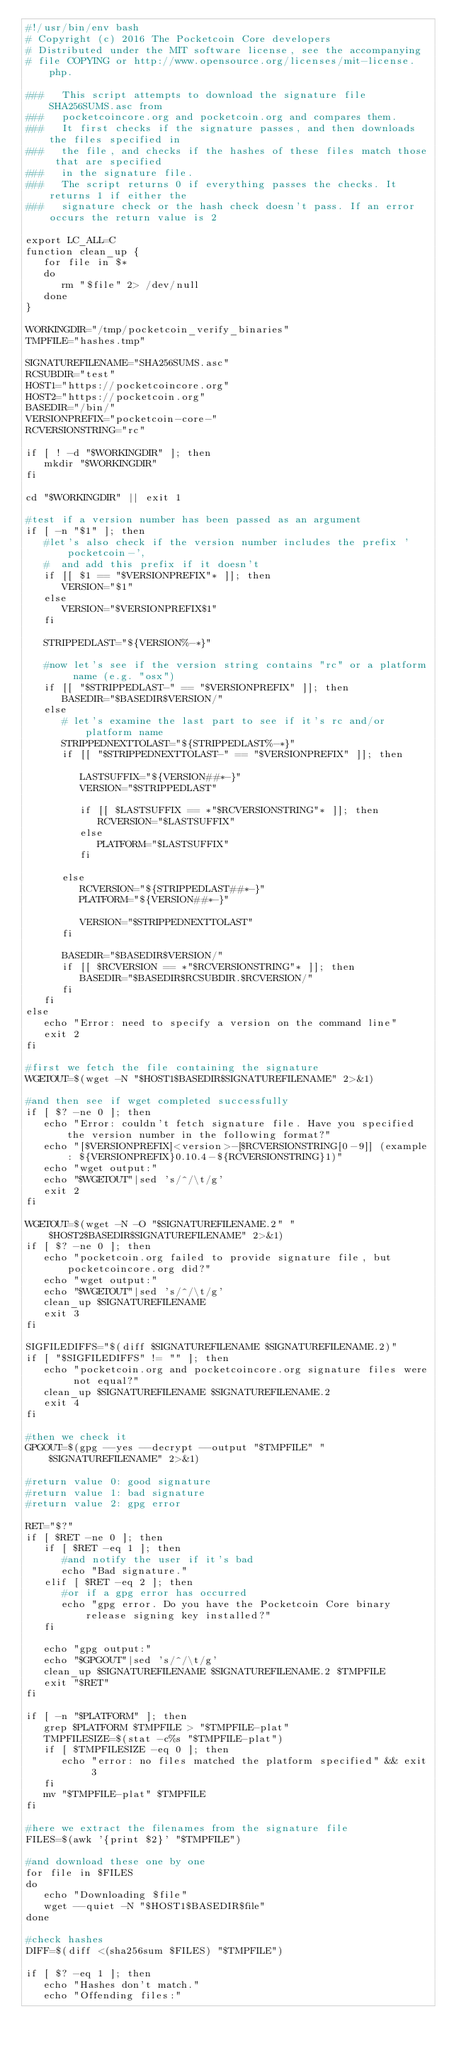<code> <loc_0><loc_0><loc_500><loc_500><_Bash_>#!/usr/bin/env bash
# Copyright (c) 2016 The Pocketcoin Core developers
# Distributed under the MIT software license, see the accompanying
# file COPYING or http://www.opensource.org/licenses/mit-license.php.

###   This script attempts to download the signature file SHA256SUMS.asc from
###   pocketcoincore.org and pocketcoin.org and compares them.
###   It first checks if the signature passes, and then downloads the files specified in
###   the file, and checks if the hashes of these files match those that are specified
###   in the signature file.
###   The script returns 0 if everything passes the checks. It returns 1 if either the
###   signature check or the hash check doesn't pass. If an error occurs the return value is 2

export LC_ALL=C
function clean_up {
   for file in $*
   do
      rm "$file" 2> /dev/null
   done
}

WORKINGDIR="/tmp/pocketcoin_verify_binaries"
TMPFILE="hashes.tmp"

SIGNATUREFILENAME="SHA256SUMS.asc"
RCSUBDIR="test"
HOST1="https://pocketcoincore.org"
HOST2="https://pocketcoin.org"
BASEDIR="/bin/"
VERSIONPREFIX="pocketcoin-core-"
RCVERSIONSTRING="rc"

if [ ! -d "$WORKINGDIR" ]; then
   mkdir "$WORKINGDIR"
fi

cd "$WORKINGDIR" || exit 1

#test if a version number has been passed as an argument
if [ -n "$1" ]; then
   #let's also check if the version number includes the prefix 'pocketcoin-',
   #  and add this prefix if it doesn't
   if [[ $1 == "$VERSIONPREFIX"* ]]; then
      VERSION="$1"
   else
      VERSION="$VERSIONPREFIX$1"
   fi

   STRIPPEDLAST="${VERSION%-*}"

   #now let's see if the version string contains "rc" or a platform name (e.g. "osx")
   if [[ "$STRIPPEDLAST-" == "$VERSIONPREFIX" ]]; then
      BASEDIR="$BASEDIR$VERSION/"
   else
      # let's examine the last part to see if it's rc and/or platform name
      STRIPPEDNEXTTOLAST="${STRIPPEDLAST%-*}"
      if [[ "$STRIPPEDNEXTTOLAST-" == "$VERSIONPREFIX" ]]; then

         LASTSUFFIX="${VERSION##*-}"
         VERSION="$STRIPPEDLAST"

         if [[ $LASTSUFFIX == *"$RCVERSIONSTRING"* ]]; then
            RCVERSION="$LASTSUFFIX"
         else
            PLATFORM="$LASTSUFFIX"
         fi

      else
         RCVERSION="${STRIPPEDLAST##*-}"
         PLATFORM="${VERSION##*-}"

         VERSION="$STRIPPEDNEXTTOLAST"
      fi

      BASEDIR="$BASEDIR$VERSION/"
      if [[ $RCVERSION == *"$RCVERSIONSTRING"* ]]; then
         BASEDIR="$BASEDIR$RCSUBDIR.$RCVERSION/"
      fi
   fi
else
   echo "Error: need to specify a version on the command line"
   exit 2
fi

#first we fetch the file containing the signature
WGETOUT=$(wget -N "$HOST1$BASEDIR$SIGNATUREFILENAME" 2>&1)

#and then see if wget completed successfully
if [ $? -ne 0 ]; then
   echo "Error: couldn't fetch signature file. Have you specified the version number in the following format?"
   echo "[$VERSIONPREFIX]<version>-[$RCVERSIONSTRING[0-9]] (example: ${VERSIONPREFIX}0.10.4-${RCVERSIONSTRING}1)"
   echo "wget output:"
   echo "$WGETOUT"|sed 's/^/\t/g'
   exit 2
fi

WGETOUT=$(wget -N -O "$SIGNATUREFILENAME.2" "$HOST2$BASEDIR$SIGNATUREFILENAME" 2>&1)
if [ $? -ne 0 ]; then
   echo "pocketcoin.org failed to provide signature file, but pocketcoincore.org did?"
   echo "wget output:"
   echo "$WGETOUT"|sed 's/^/\t/g'
   clean_up $SIGNATUREFILENAME
   exit 3
fi

SIGFILEDIFFS="$(diff $SIGNATUREFILENAME $SIGNATUREFILENAME.2)"
if [ "$SIGFILEDIFFS" != "" ]; then
   echo "pocketcoin.org and pocketcoincore.org signature files were not equal?"
   clean_up $SIGNATUREFILENAME $SIGNATUREFILENAME.2
   exit 4
fi

#then we check it
GPGOUT=$(gpg --yes --decrypt --output "$TMPFILE" "$SIGNATUREFILENAME" 2>&1)

#return value 0: good signature
#return value 1: bad signature
#return value 2: gpg error

RET="$?"
if [ $RET -ne 0 ]; then
   if [ $RET -eq 1 ]; then
      #and notify the user if it's bad
      echo "Bad signature."
   elif [ $RET -eq 2 ]; then
      #or if a gpg error has occurred
      echo "gpg error. Do you have the Pocketcoin Core binary release signing key installed?"
   fi

   echo "gpg output:"
   echo "$GPGOUT"|sed 's/^/\t/g'
   clean_up $SIGNATUREFILENAME $SIGNATUREFILENAME.2 $TMPFILE
   exit "$RET"
fi

if [ -n "$PLATFORM" ]; then
   grep $PLATFORM $TMPFILE > "$TMPFILE-plat"
   TMPFILESIZE=$(stat -c%s "$TMPFILE-plat")
   if [ $TMPFILESIZE -eq 0 ]; then
      echo "error: no files matched the platform specified" && exit 3
   fi
   mv "$TMPFILE-plat" $TMPFILE
fi

#here we extract the filenames from the signature file
FILES=$(awk '{print $2}' "$TMPFILE")

#and download these one by one
for file in $FILES
do
   echo "Downloading $file"
   wget --quiet -N "$HOST1$BASEDIR$file"
done

#check hashes
DIFF=$(diff <(sha256sum $FILES) "$TMPFILE")

if [ $? -eq 1 ]; then
   echo "Hashes don't match."
   echo "Offending files:"</code> 